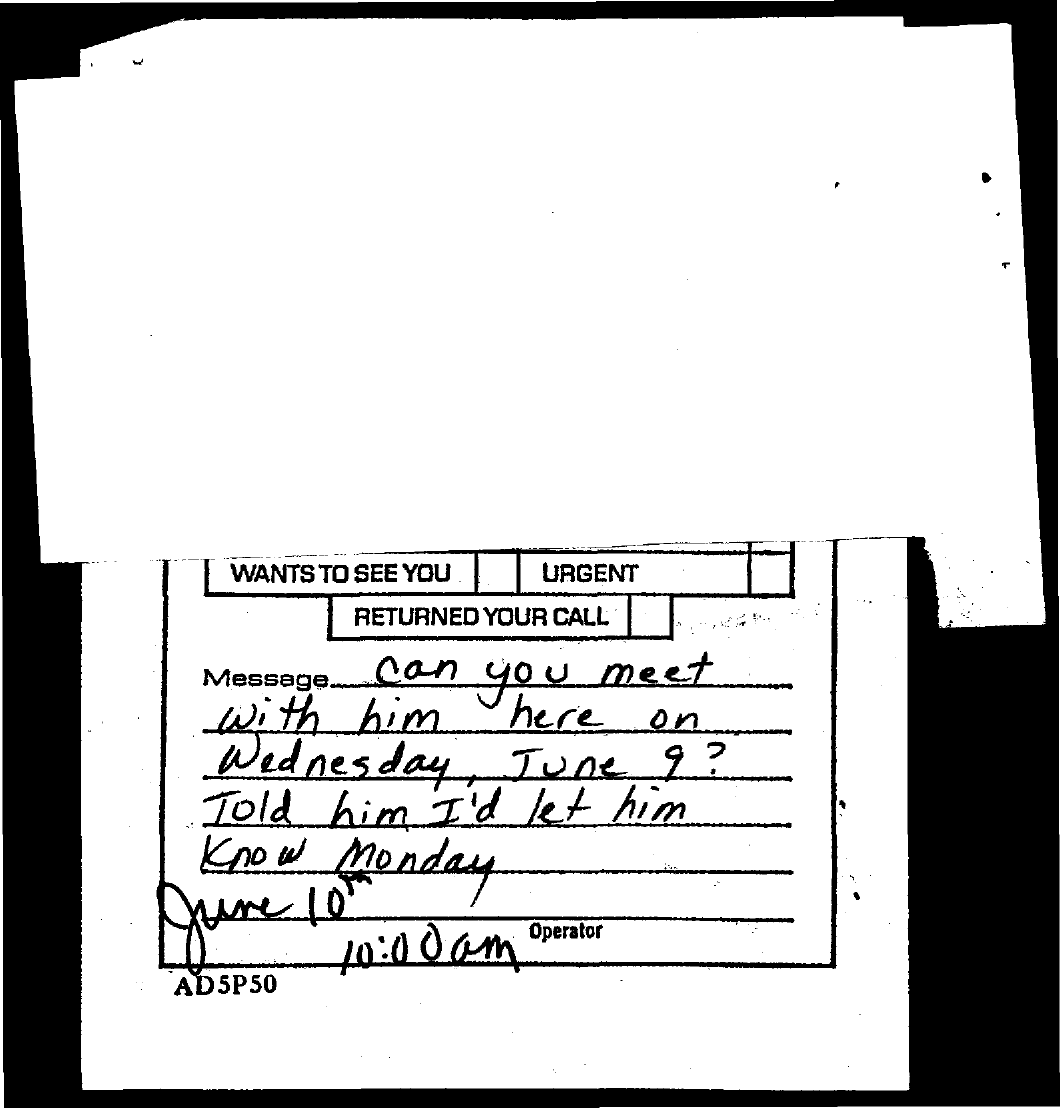Outline some significant characteristics in this image. The time mentioned in the document is 10:00 am. 